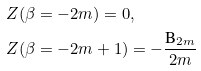<formula> <loc_0><loc_0><loc_500><loc_500>Z ( \beta & = - 2 m ) = 0 , \\ Z ( \beta & = - 2 m + 1 ) = - \frac { \text {B} _ { 2 m } } { 2 m }</formula> 